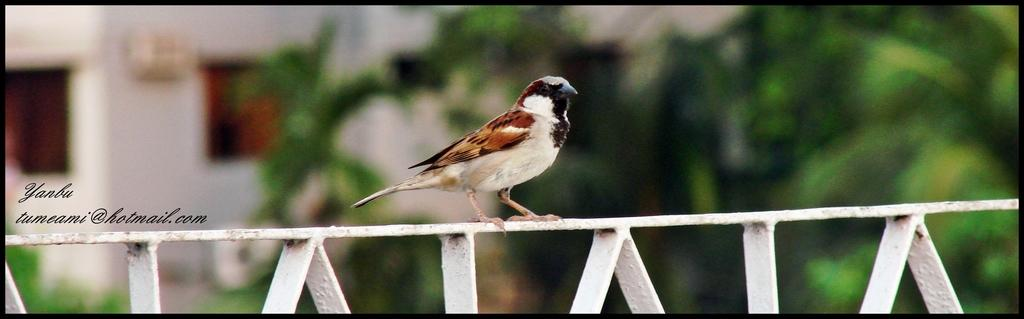What type of animal is present in the image? There is a bird in the image. What is the bird standing on? The bird is standing on an iron object. Can you describe the color of the iron object? The iron object is in white and brown color. What type of bread is being served on the stage in the image? There is no bread or stage present in the image; it features a bird standing on an iron object. 